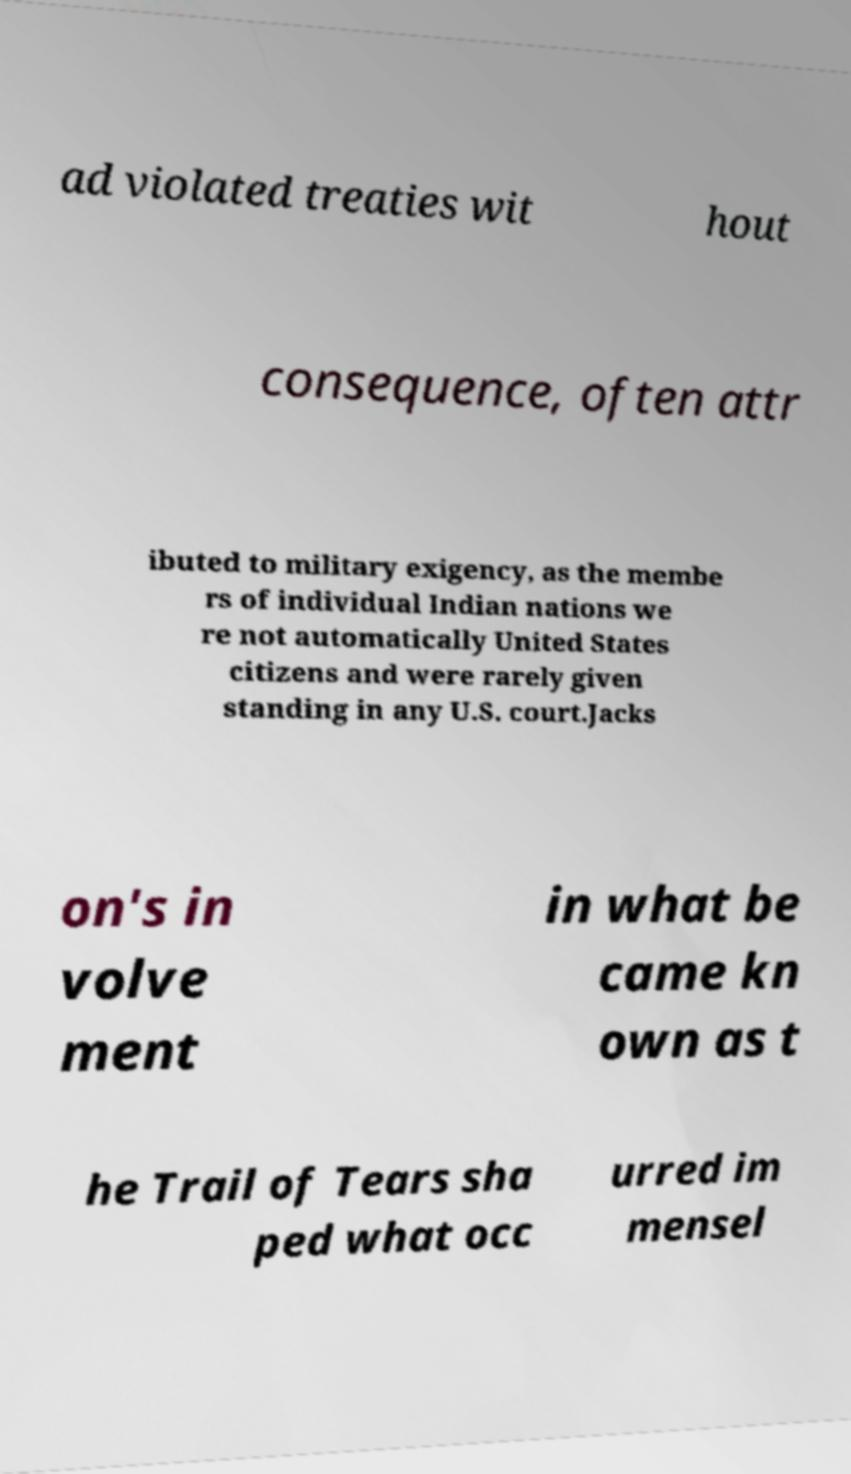I need the written content from this picture converted into text. Can you do that? ad violated treaties wit hout consequence, often attr ibuted to military exigency, as the membe rs of individual Indian nations we re not automatically United States citizens and were rarely given standing in any U.S. court.Jacks on's in volve ment in what be came kn own as t he Trail of Tears sha ped what occ urred im mensel 